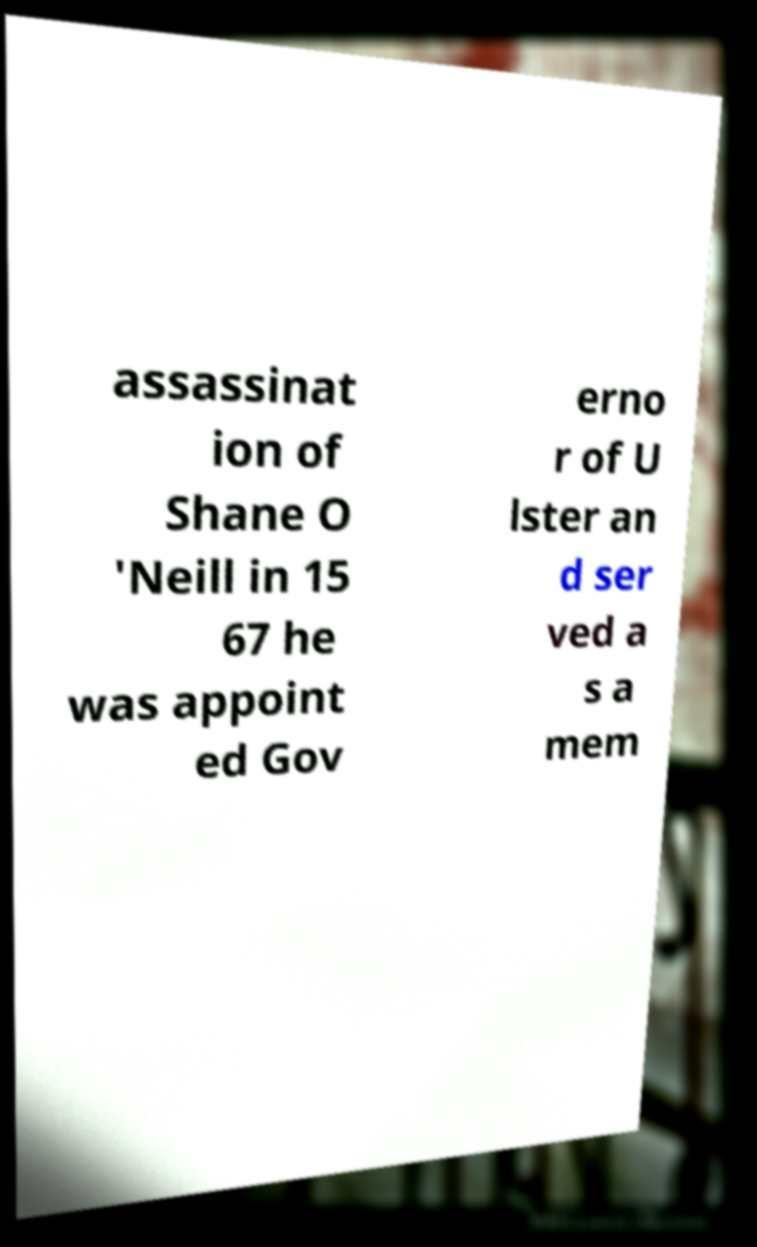Could you extract and type out the text from this image? assassinat ion of Shane O 'Neill in 15 67 he was appoint ed Gov erno r of U lster an d ser ved a s a mem 